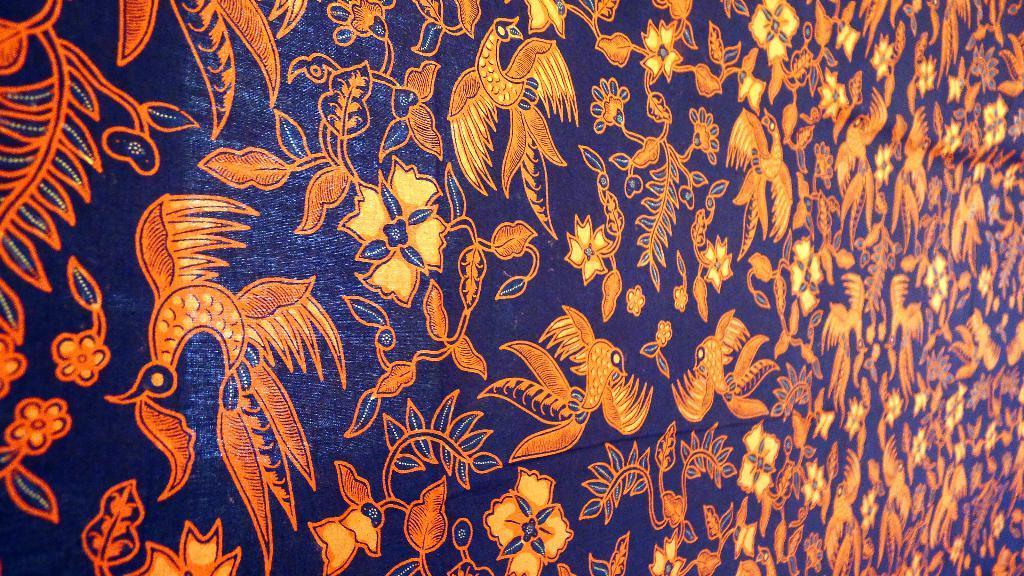In one or two sentences, can you explain what this image depicts? Here we can see an orange design on this blue surface.  